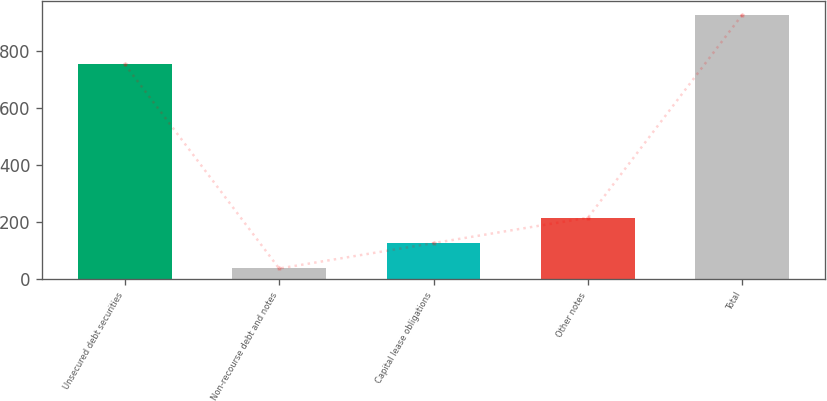Convert chart. <chart><loc_0><loc_0><loc_500><loc_500><bar_chart><fcel>Unsecured debt securities<fcel>Non-recourse debt and notes<fcel>Capital lease obligations<fcel>Other notes<fcel>Total<nl><fcel>755<fcel>38<fcel>127.1<fcel>216.2<fcel>929<nl></chart> 